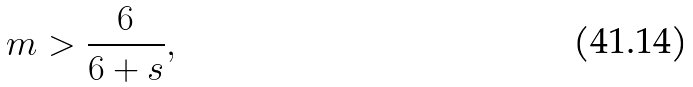Convert formula to latex. <formula><loc_0><loc_0><loc_500><loc_500>m > \frac { 6 } { 6 + s } ,</formula> 